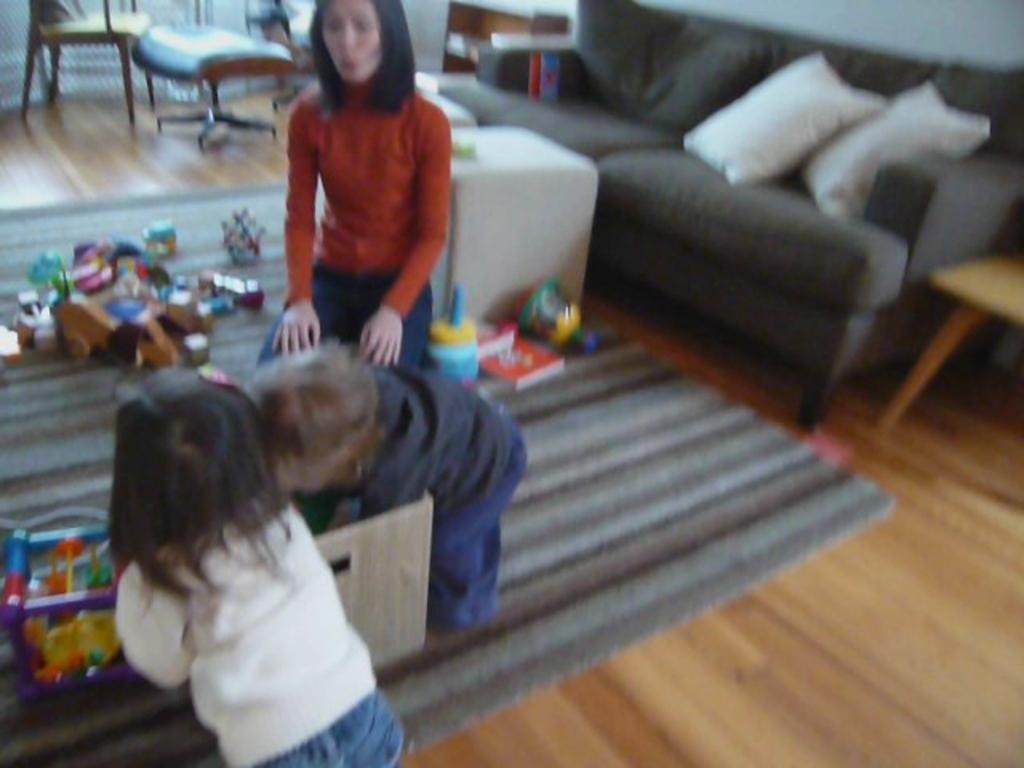In one or two sentences, can you explain what this image depicts? A picture inside of a room. Floor with carpet. These are couches with pillows. Beside this couch there is a table. We can able to see chairs. This woman is sitting on a chair. Beside this woman there are toys. These 2 kids are on floor. In-front of this kid there is a box. 